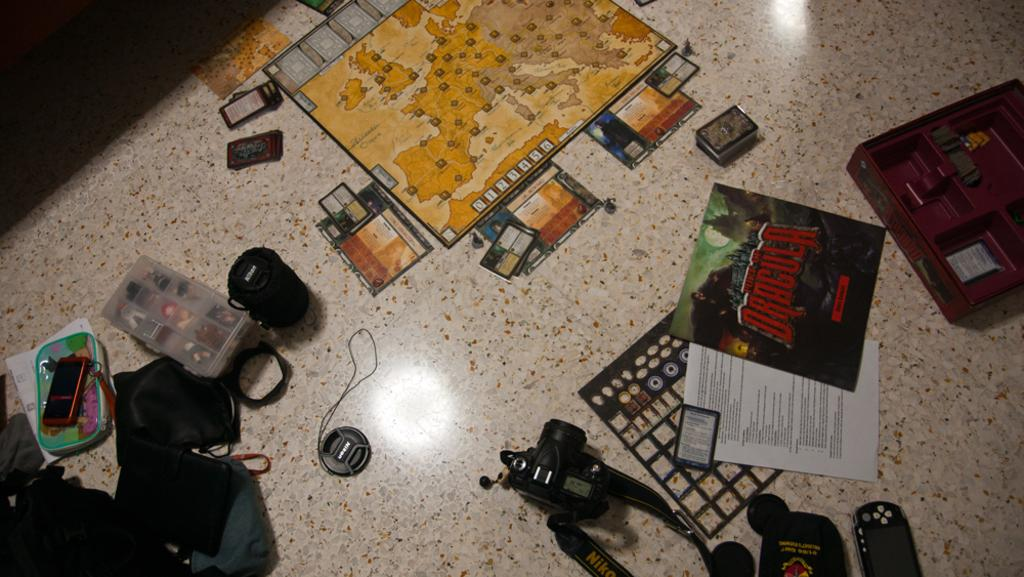What is the main object in the image? There is a camera in the image. What part of the camera is visible in the image? There is a camera lens in the image. What device might be used to control the camera remotely? There is a remote in the image. What type of electronic device is also present in the image? There is a mobile phone in the image. What is the box in the image used for? It is not specified what the box is used for in the image. What type of items are present in the image that might be used for carrying or storing things? There are bags in the image. What type of items are present in the image that might be used for writing or documentation? There are papers in the image. What other items can be seen on the floor in the image? There are other items on the floor in the image, but their specific nature is not mentioned. What type of arch can be seen in the image? There is no arch present in the image. How does the fork react to the camera in the image? There is no fork present in the image, so it cannot react to the camera. 